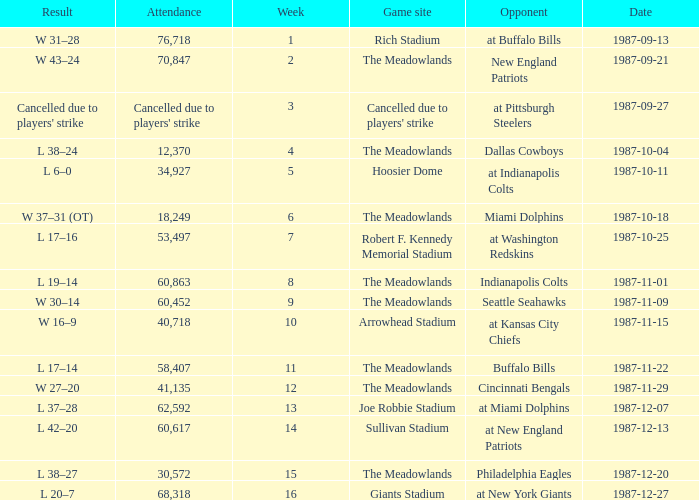Who did the Jets play in their post-week 15 game? At new york giants. Would you mind parsing the complete table? {'header': ['Result', 'Attendance', 'Week', 'Game site', 'Opponent', 'Date'], 'rows': [['W 31–28', '76,718', '1', 'Rich Stadium', 'at Buffalo Bills', '1987-09-13'], ['W 43–24', '70,847', '2', 'The Meadowlands', 'New England Patriots', '1987-09-21'], ["Cancelled due to players' strike", "Cancelled due to players' strike", '3', "Cancelled due to players' strike", 'at Pittsburgh Steelers', '1987-09-27'], ['L 38–24', '12,370', '4', 'The Meadowlands', 'Dallas Cowboys', '1987-10-04'], ['L 6–0', '34,927', '5', 'Hoosier Dome', 'at Indianapolis Colts', '1987-10-11'], ['W 37–31 (OT)', '18,249', '6', 'The Meadowlands', 'Miami Dolphins', '1987-10-18'], ['L 17–16', '53,497', '7', 'Robert F. Kennedy Memorial Stadium', 'at Washington Redskins', '1987-10-25'], ['L 19–14', '60,863', '8', 'The Meadowlands', 'Indianapolis Colts', '1987-11-01'], ['W 30–14', '60,452', '9', 'The Meadowlands', 'Seattle Seahawks', '1987-11-09'], ['W 16–9', '40,718', '10', 'Arrowhead Stadium', 'at Kansas City Chiefs', '1987-11-15'], ['L 17–14', '58,407', '11', 'The Meadowlands', 'Buffalo Bills', '1987-11-22'], ['W 27–20', '41,135', '12', 'The Meadowlands', 'Cincinnati Bengals', '1987-11-29'], ['L 37–28', '62,592', '13', 'Joe Robbie Stadium', 'at Miami Dolphins', '1987-12-07'], ['L 42–20', '60,617', '14', 'Sullivan Stadium', 'at New England Patriots', '1987-12-13'], ['L 38–27', '30,572', '15', 'The Meadowlands', 'Philadelphia Eagles', '1987-12-20'], ['L 20–7', '68,318', '16', 'Giants Stadium', 'at New York Giants', '1987-12-27']]} 